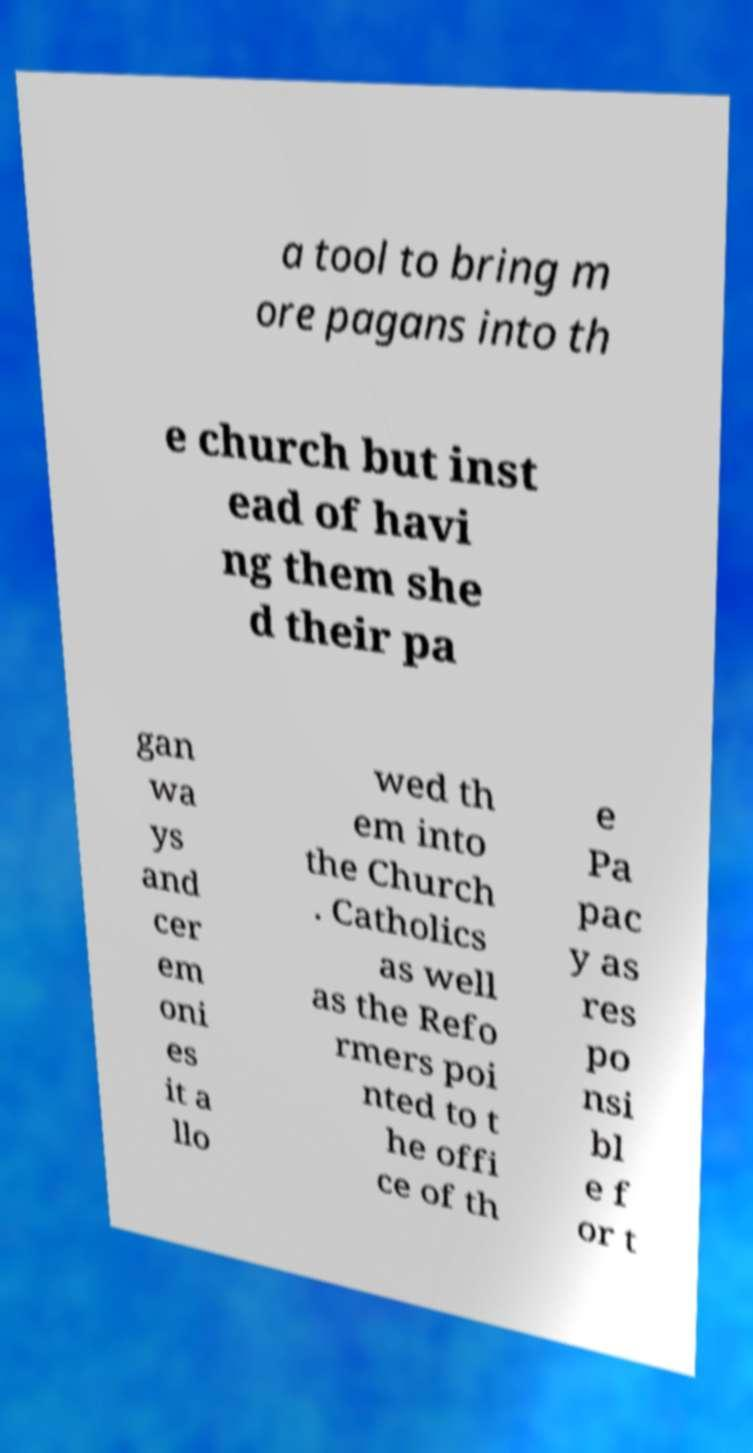Please read and relay the text visible in this image. What does it say? a tool to bring m ore pagans into th e church but inst ead of havi ng them she d their pa gan wa ys and cer em oni es it a llo wed th em into the Church . Catholics as well as the Refo rmers poi nted to t he offi ce of th e Pa pac y as res po nsi bl e f or t 